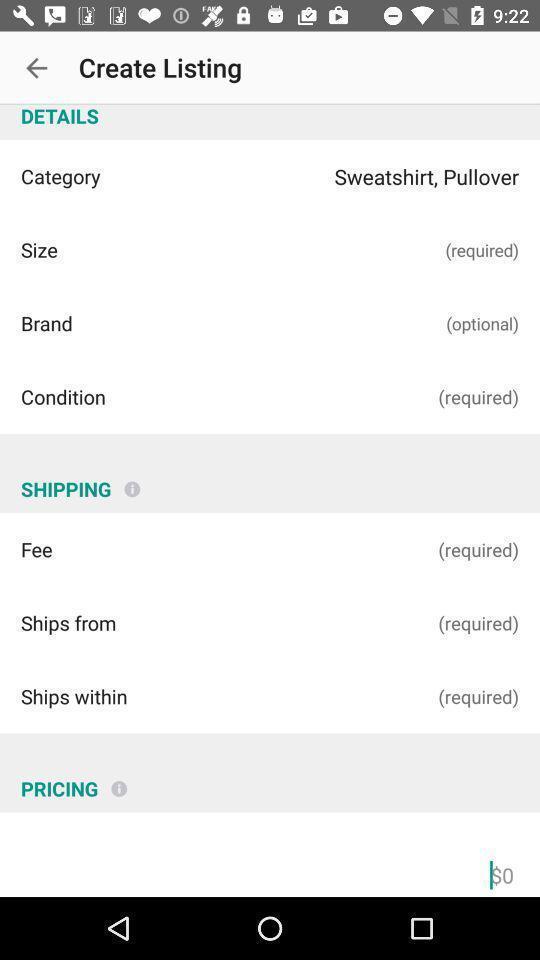Give me a summary of this screen capture. Shipping and details of the shopping app. 